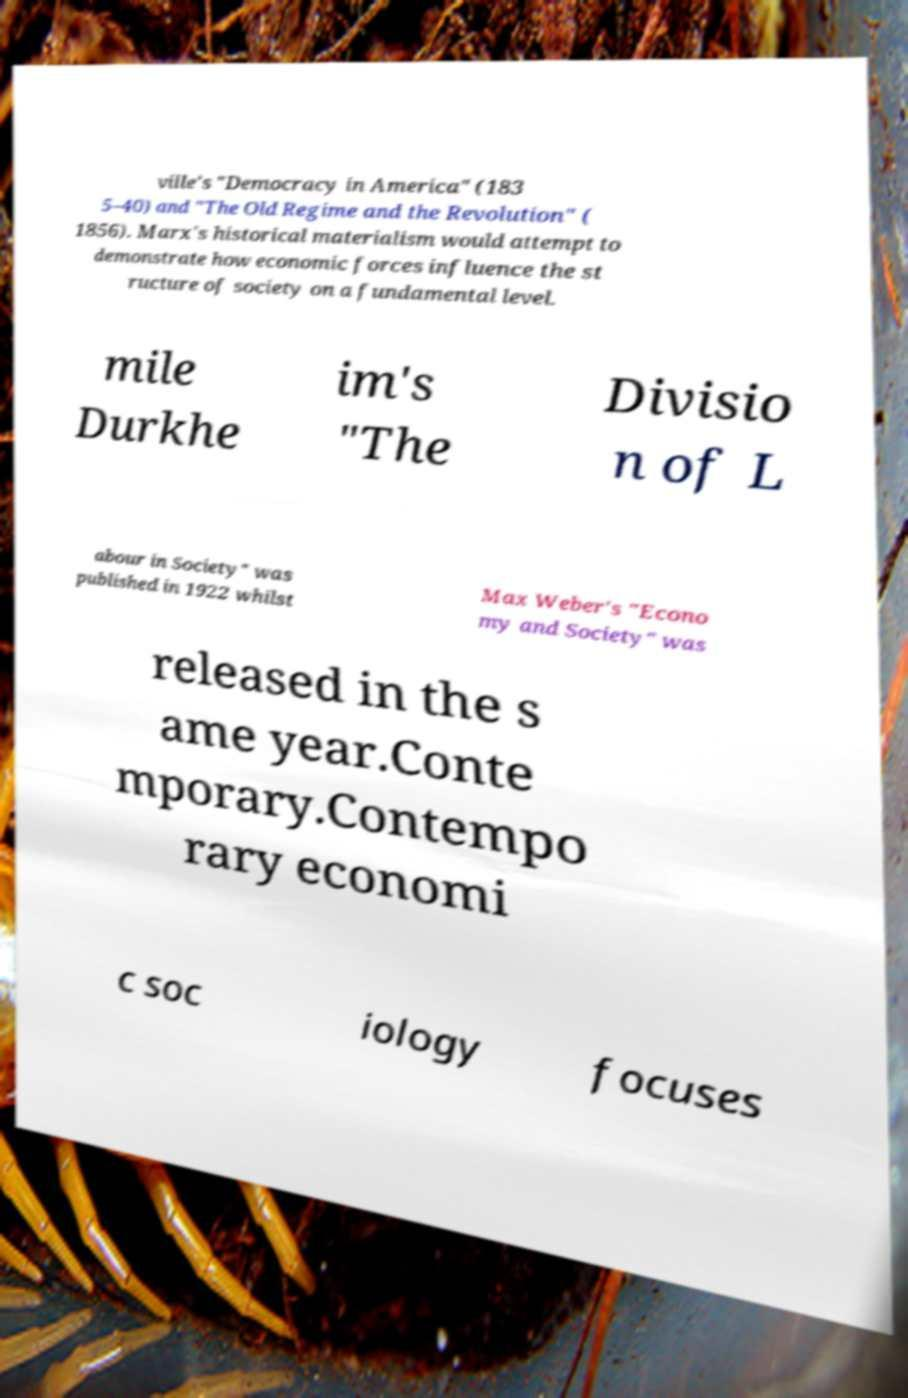What messages or text are displayed in this image? I need them in a readable, typed format. ville's "Democracy in America" (183 5–40) and "The Old Regime and the Revolution" ( 1856). Marx's historical materialism would attempt to demonstrate how economic forces influence the st ructure of society on a fundamental level. mile Durkhe im's "The Divisio n of L abour in Society" was published in 1922 whilst Max Weber's "Econo my and Society" was released in the s ame year.Conte mporary.Contempo rary economi c soc iology focuses 